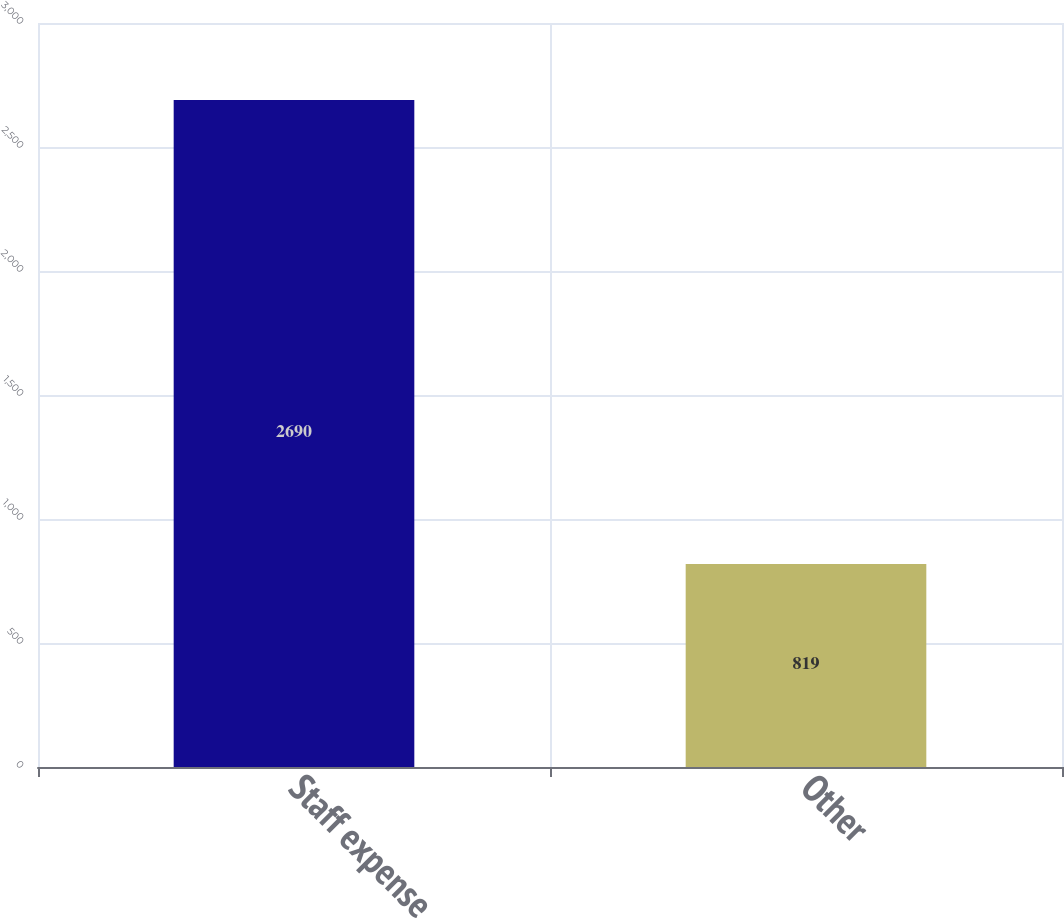Convert chart. <chart><loc_0><loc_0><loc_500><loc_500><bar_chart><fcel>Staff expense<fcel>Other<nl><fcel>2690<fcel>819<nl></chart> 